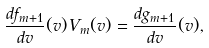Convert formula to latex. <formula><loc_0><loc_0><loc_500><loc_500>\frac { d f _ { m + 1 } } { d v } ( v ) V _ { m } ( v ) = \frac { d g _ { m + 1 } } { d v } ( v ) ,</formula> 